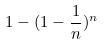Convert formula to latex. <formula><loc_0><loc_0><loc_500><loc_500>1 - ( 1 - \frac { 1 } { n } ) ^ { n }</formula> 